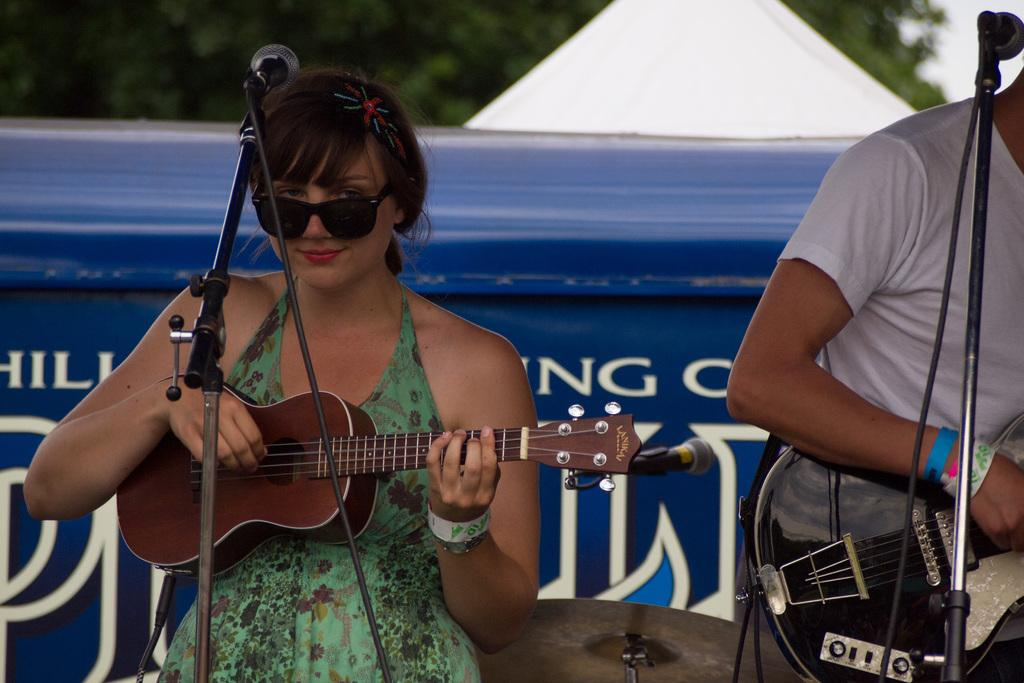How many people are in the image? There are two persons in the image. What are the persons doing in the image? The persons are standing in front of a microphone. Can you describe one of the persons in the image? One of the persons is a female, and she is wearing spectacles. What is the female person doing in the image? The female person is playing a guitar. What type of twig is the female person holding in the image? There is no twig present in the image; the female person is playing a guitar. How is the hook attached to the guitar in the image? There is no hook mentioned or visible in the image; the female person is playing a guitar. 